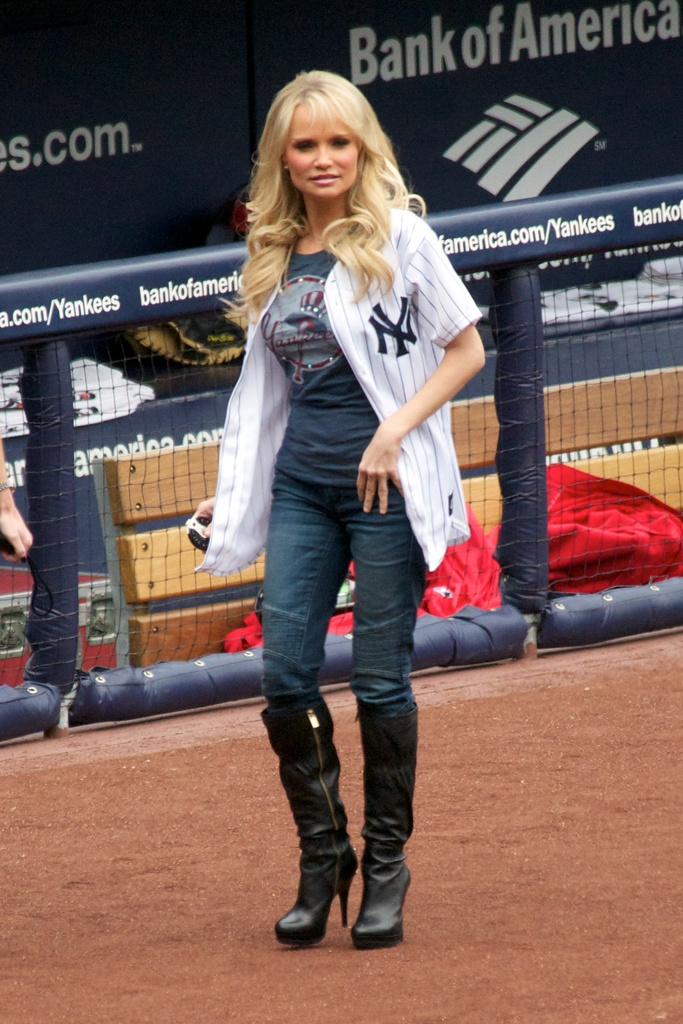Explain the significance of the Bank of America branding in the background. The Bank of America branding seen on the digital boards around the stadium indicates a sponsorship or partnership with the Yankees, likely involving financial support or promotional activities linked to the team. 